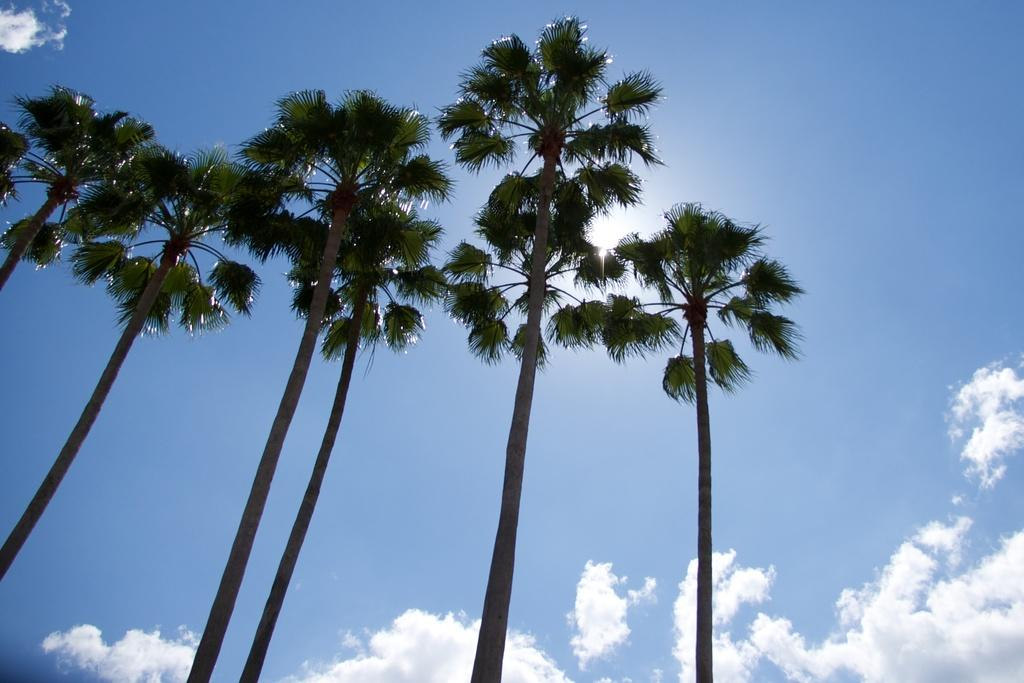What type of vegetation can be seen in the image? There are trees in the image. What part of the natural environment is visible in the image? The sky is visible in the image. What letters can be seen on the head of the giraffe in the image? There is no giraffe present in the image, and therefore no head or letters can be observed. 